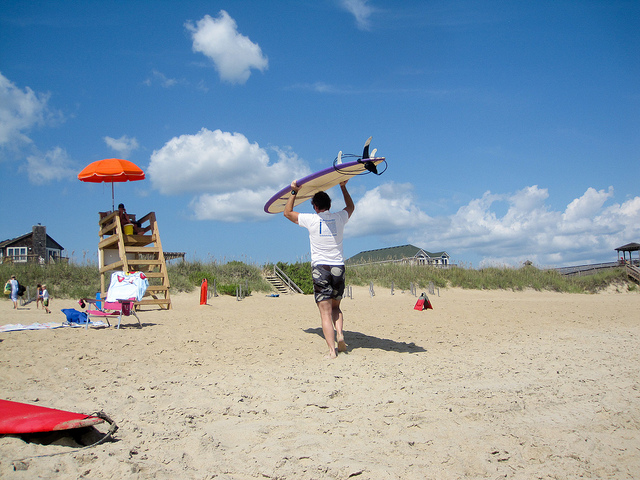What activities are people doing at the beach? In the image, there's a person carrying a surfboard, seemingly heading to catch some waves. Another individual appears to be taking a leisurely walk along the beach. Near a lifeguard stand, someone is seated possibly enjoying the seaside ambiance or keeping an eye on the swimmers. 